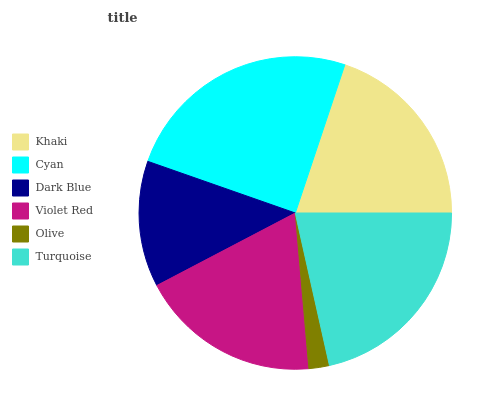Is Olive the minimum?
Answer yes or no. Yes. Is Cyan the maximum?
Answer yes or no. Yes. Is Dark Blue the minimum?
Answer yes or no. No. Is Dark Blue the maximum?
Answer yes or no. No. Is Cyan greater than Dark Blue?
Answer yes or no. Yes. Is Dark Blue less than Cyan?
Answer yes or no. Yes. Is Dark Blue greater than Cyan?
Answer yes or no. No. Is Cyan less than Dark Blue?
Answer yes or no. No. Is Khaki the high median?
Answer yes or no. Yes. Is Violet Red the low median?
Answer yes or no. Yes. Is Turquoise the high median?
Answer yes or no. No. Is Dark Blue the low median?
Answer yes or no. No. 